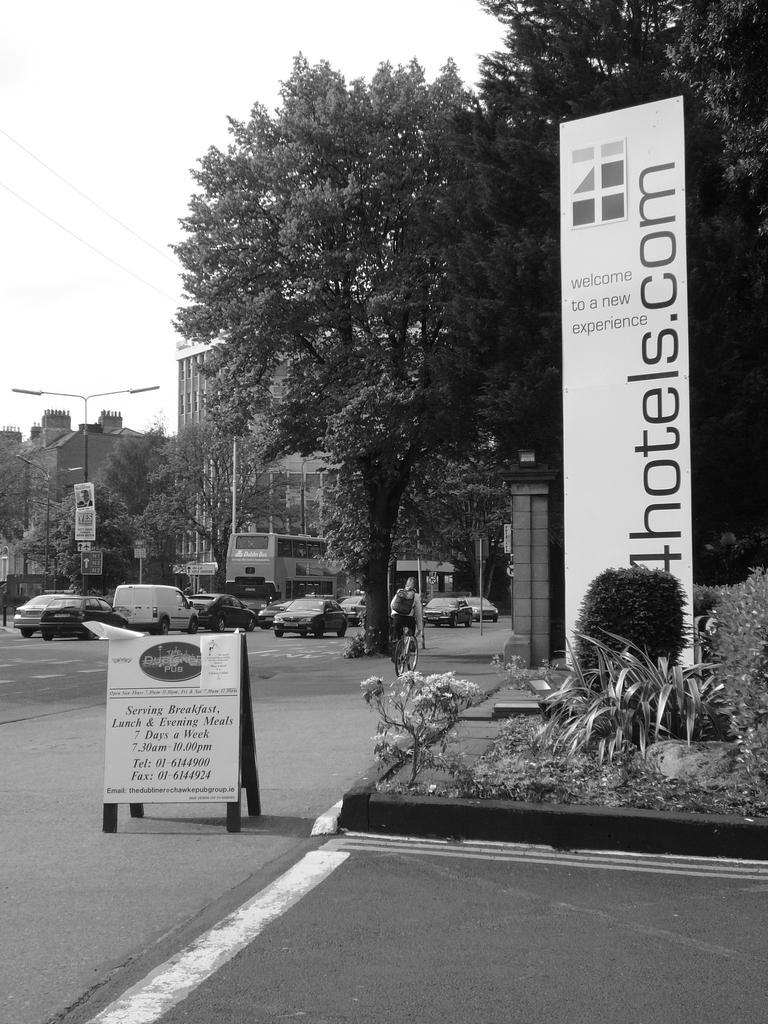How would you summarize this image in a sentence or two? In this image there are some trees, buildings, poles, lights, boards and there are are some vehicles. In the center there is one person who is sitting on a cycle, and at the bottom there is a walkway. And on the right side of the image there are some plants. At the top there is sky and some wires. 